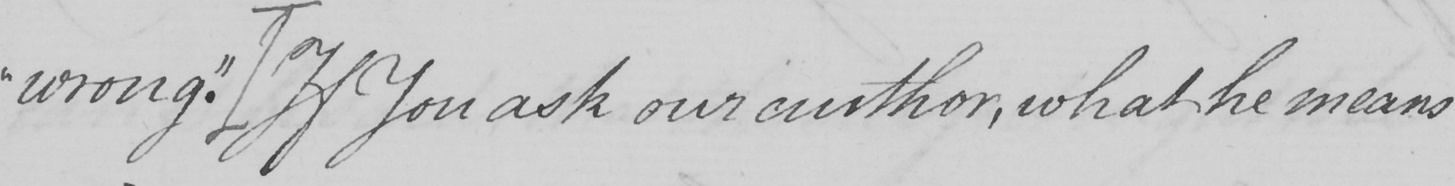Please provide the text content of this handwritten line. wrong." [If You ask our author, what he means 